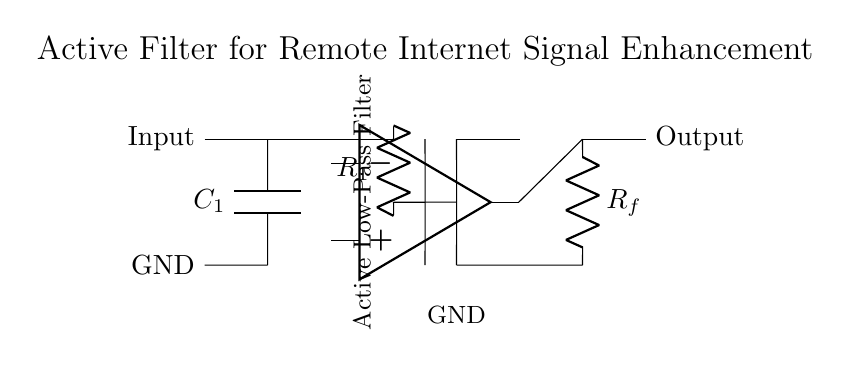What type of filter is represented in the circuit? The circuit diagram depicts an active low-pass filter, signified by the presence of an operational amplifier and specific RC components to allow low-frequency signals to pass while attenuating higher frequency signals.
Answer: Active low-pass filter What is the role of the capacitor in the circuit? The capacitor, labeled as C1, stores energy and influences the cutoff frequency of the filter, affecting how signals are filtered based on their frequency. It acts as a barrier to high-frequency signals, which are shunted to ground.
Answer: Coupling capacitor What component is responsible for feedback in this circuit? The resistor labeled as Rf connects the output of the operational amplifier back to its inverting input, establishing feedback that affects the gain and frequency response of the filter.
Answer: Rf How many resistors are present in the circuit? There are two resistors shown in the circuit diagram: R1 and Rf. Their values will determine the filter's gain and cut-off characteristics.
Answer: Two resistors Which node is connected to ground? The node at the bottom of capacitor C1 and resistor R1 is connected to ground, providing a reference point for the circuit and allowing return paths for the current.
Answer: Bottom node at C1 and R1 What effect does the feedback resistor have on the output signal? The feedback resistor Rf influences the gain of the active filter by setting the ratio of feedback taken from the output to the input, which determines how amplified the output signal is relative to the input.
Answer: Gain of the output signal 